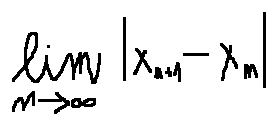<formula> <loc_0><loc_0><loc_500><loc_500>\lim \lim i t s _ { n \rightarrow \infty } | x _ { n + 1 } - x _ { n } |</formula> 